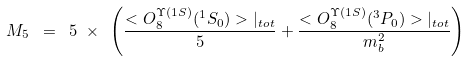Convert formula to latex. <formula><loc_0><loc_0><loc_500><loc_500>M _ { 5 } \ = \ 5 \ { \times } \ \left ( \frac { < O _ { 8 } ^ { \Upsilon ( 1 S ) } ( ^ { 1 } S _ { 0 } ) > { | } _ { t o t } } { 5 } + \frac { < O _ { 8 } ^ { \Upsilon ( 1 S ) } ( ^ { 3 } P _ { 0 } ) > { | } _ { t o t } } { m _ { b } ^ { 2 } } \right )</formula> 